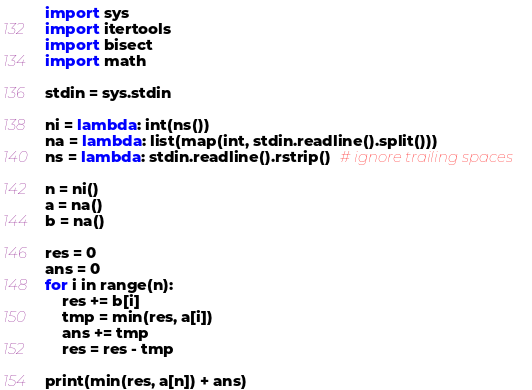Convert code to text. <code><loc_0><loc_0><loc_500><loc_500><_Python_>import sys
import itertools
import bisect
import math

stdin = sys.stdin

ni = lambda: int(ns())
na = lambda: list(map(int, stdin.readline().split()))
ns = lambda: stdin.readline().rstrip()  # ignore trailing spaces

n = ni()
a = na()
b = na()

res = 0
ans = 0
for i in range(n):
    res += b[i]
    tmp = min(res, a[i])
    ans += tmp
    res = res - tmp

print(min(res, a[n]) + ans)


</code> 